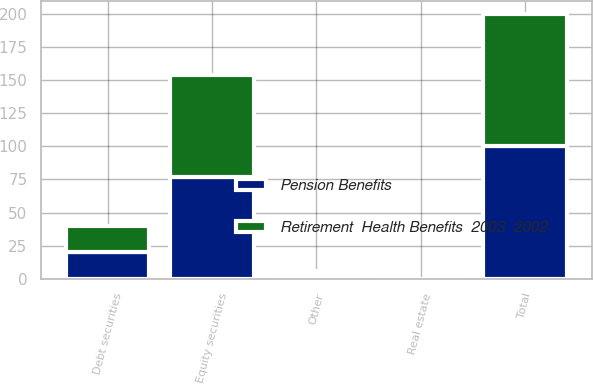<chart> <loc_0><loc_0><loc_500><loc_500><stacked_bar_chart><ecel><fcel>Equity securities<fcel>Debt securities<fcel>Real estate<fcel>Other<fcel>Total<nl><fcel>Retirement  Health Benefits  2003  2002<fcel>77<fcel>20<fcel>0<fcel>3<fcel>100<nl><fcel>Pension Benefits<fcel>77<fcel>20<fcel>0<fcel>3<fcel>100<nl></chart> 